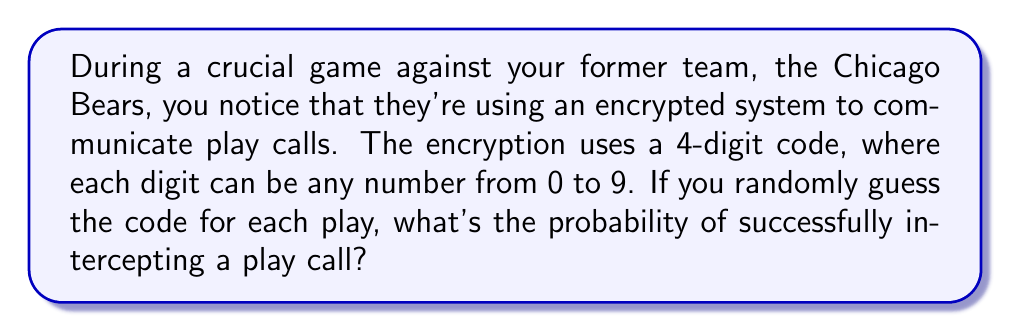Help me with this question. Let's approach this step-by-step:

1) First, we need to determine the total number of possible 4-digit codes:
   - Each digit can be any number from 0 to 9, so there are 10 choices for each digit.
   - For a 4-digit code, we have 10 choices for each of the 4 positions.
   - The total number of possible codes is therefore $10 \times 10 \times 10 \times 10 = 10^4 = 10,000$.

2) Now, for a successful interception, we need to guess the correct code out of all these possibilities.
   - There is only 1 correct code out of 10,000 possible codes.

3) The probability of a successful guess is:

   $$P(\text{successful interception}) = \frac{\text{number of favorable outcomes}}{\text{total number of possible outcomes}}$$

   $$P(\text{successful interception}) = \frac{1}{10,000} = 0.0001$$

4) We can also express this as a percentage:

   $$0.0001 \times 100\% = 0.01\%$$

Therefore, the probability of successfully intercepting a play call by randomly guessing the 4-digit code is 0.0001 or 0.01%.
Answer: $\frac{1}{10,000}$ or $0.0001$ or $0.01\%$ 